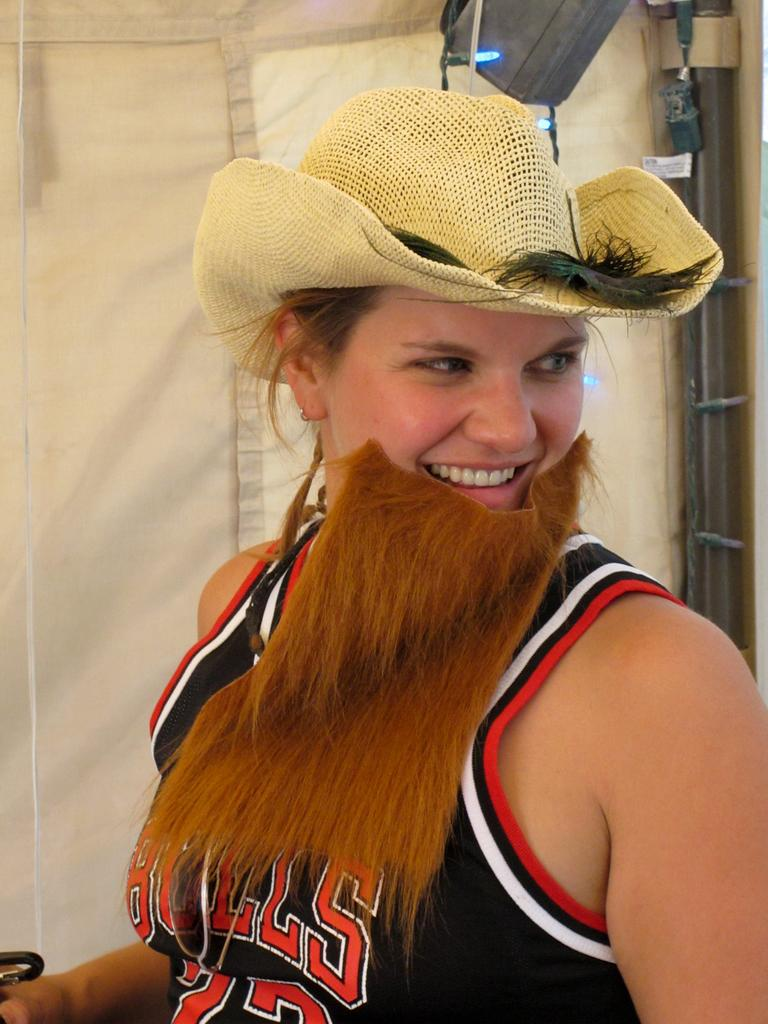<image>
Describe the image concisely. A woman wearing a fake beard is also wearing a Bulls jersey. 